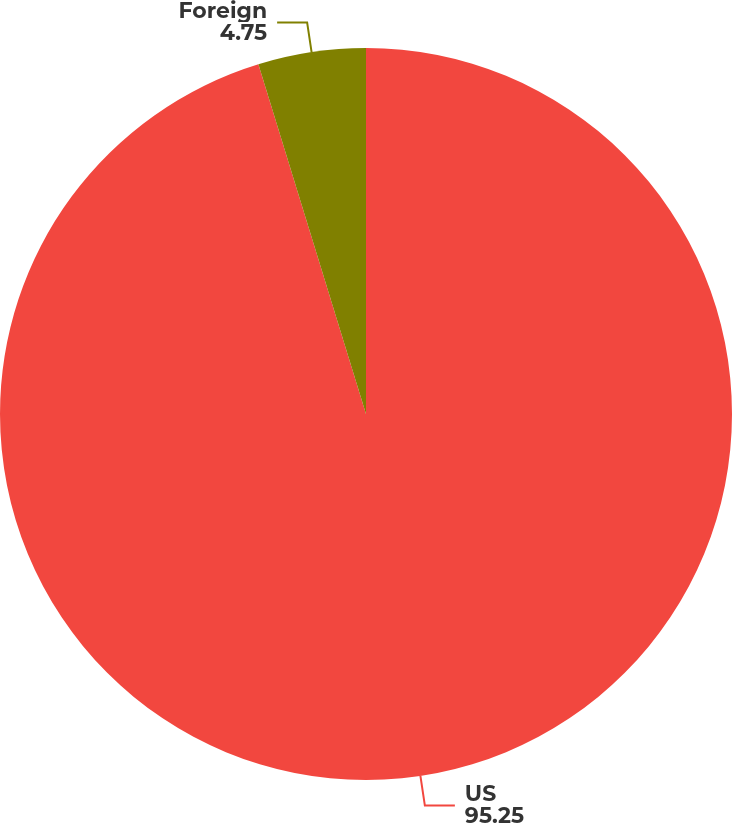<chart> <loc_0><loc_0><loc_500><loc_500><pie_chart><fcel>US<fcel>Foreign<nl><fcel>95.25%<fcel>4.75%<nl></chart> 